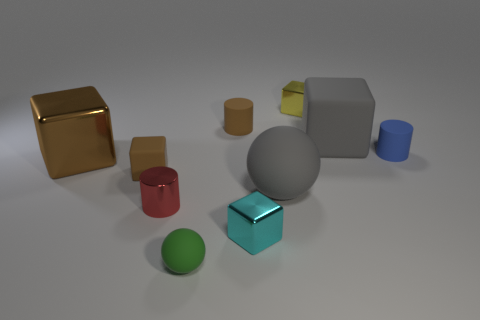Subtract all shiny cylinders. How many cylinders are left? 2 Subtract 4 blocks. How many blocks are left? 1 Subtract all gray blocks. How many blocks are left? 4 Subtract all gray cylinders. How many brown cubes are left? 2 Add 5 brown things. How many brown things are left? 8 Add 4 purple shiny blocks. How many purple shiny blocks exist? 4 Subtract 1 brown cylinders. How many objects are left? 9 Subtract all balls. How many objects are left? 8 Subtract all green cylinders. Subtract all blue cubes. How many cylinders are left? 3 Subtract all big brown rubber balls. Subtract all tiny green matte spheres. How many objects are left? 9 